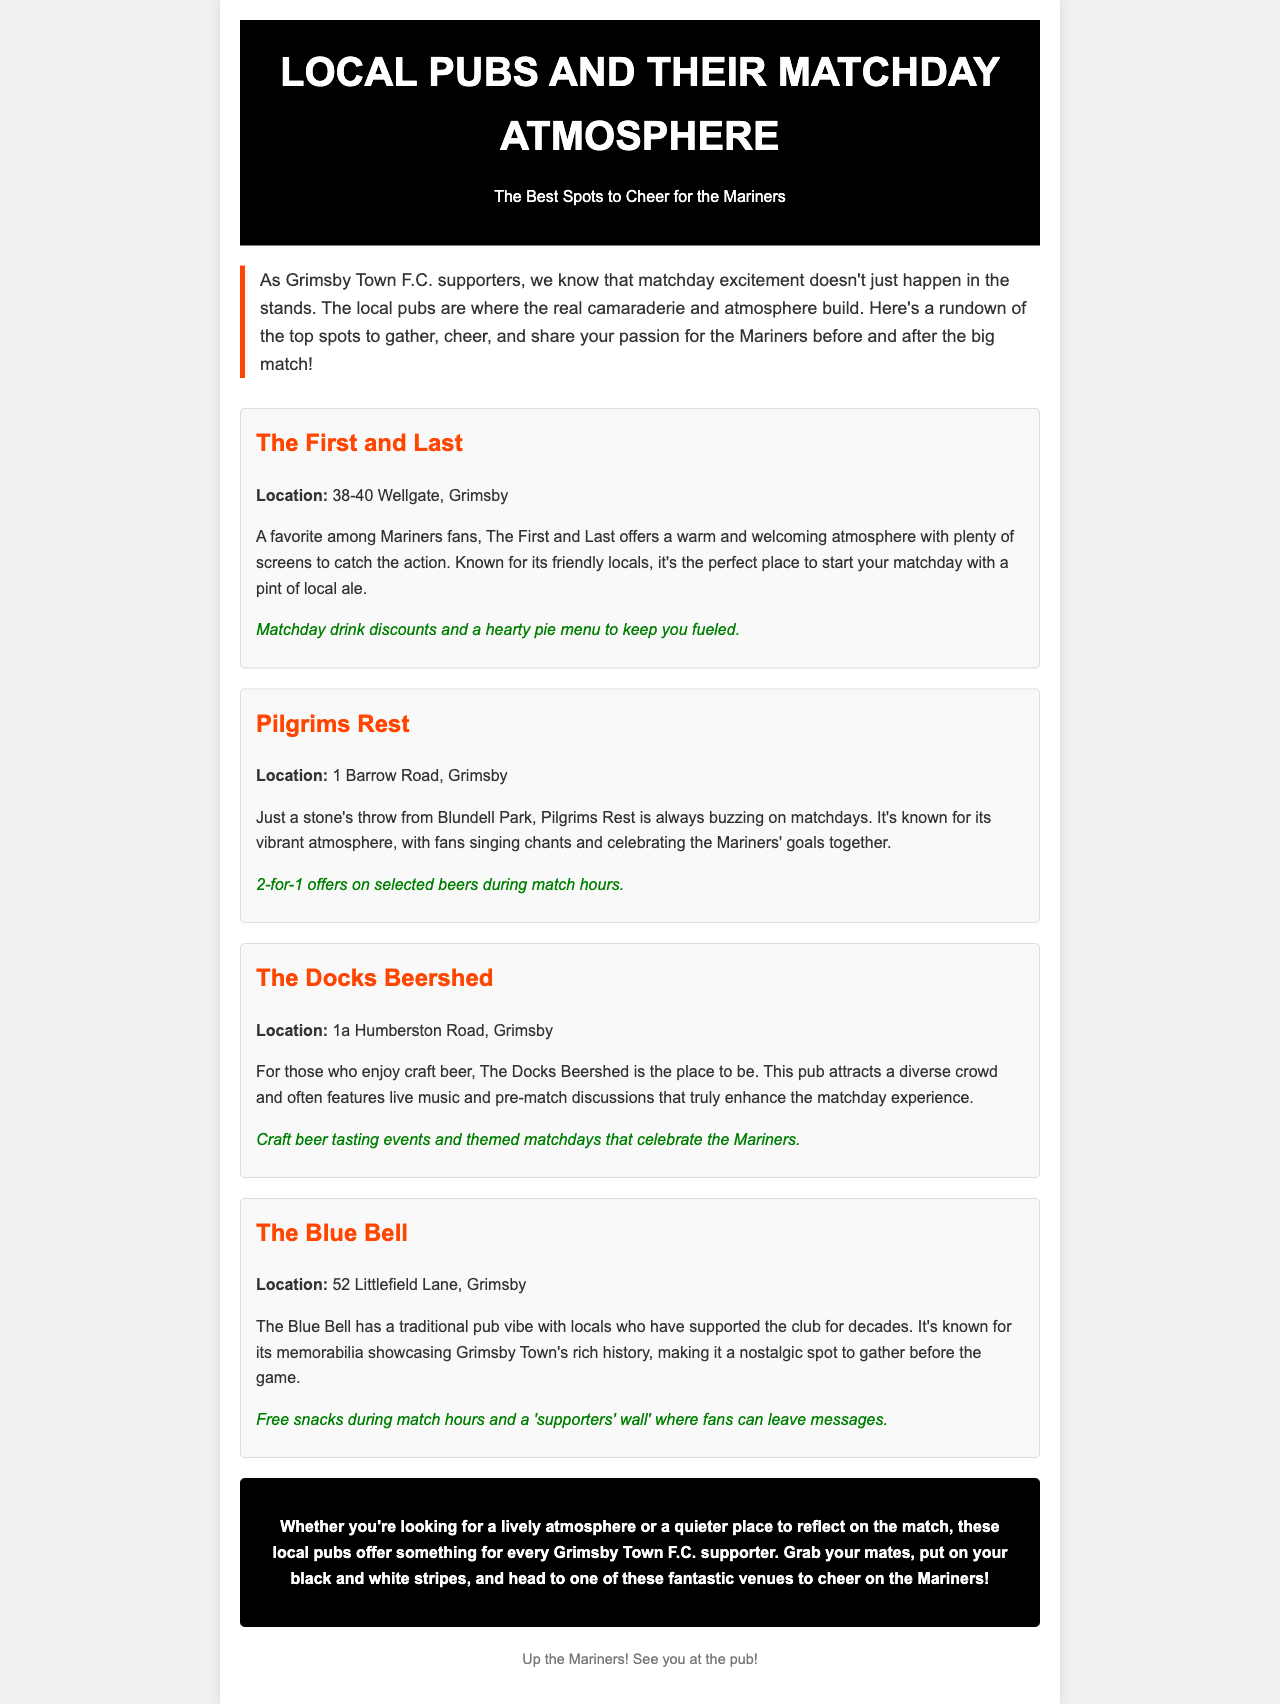What is the title of the newsletter? The title is explicitly stated in the header of the document.
Answer: Local Pubs and Their Matchday Atmosphere How many pubs are mentioned in the newsletter? Each pub is listed in a separate section, and there are four in total.
Answer: Four What special offer does The First and Last have? The specific offer is provided in the description of The First and Last pub.
Answer: Matchday drink discounts What is the location of Pilgrims Rest? The location is clearly mentioned right after the pub's name.
Answer: 1 Barrow Road, Grimsby Which pub is known for its craft beer? This information can be found in the description of The Docks Beershed.
Answer: The Docks Beershed What is a unique feature of The Blue Bell? The description highlights a distinct aspect of The Blue Bell pub.
Answer: 'Supporters' wall' Why is Pilgrims Rest popular on matchdays? The buzzing atmosphere and fan interactions are noted in its description.
Answer: Vibrant atmosphere What can fans expect at The Docks Beershed during matchdays? The document mentions activities that take place in this pub specifically during matchdays.
Answer: Craft beer tasting events What type of atmosphere does The First and Last offer? The description of this pub indicates its atmosphere.
Answer: Warm and welcoming 